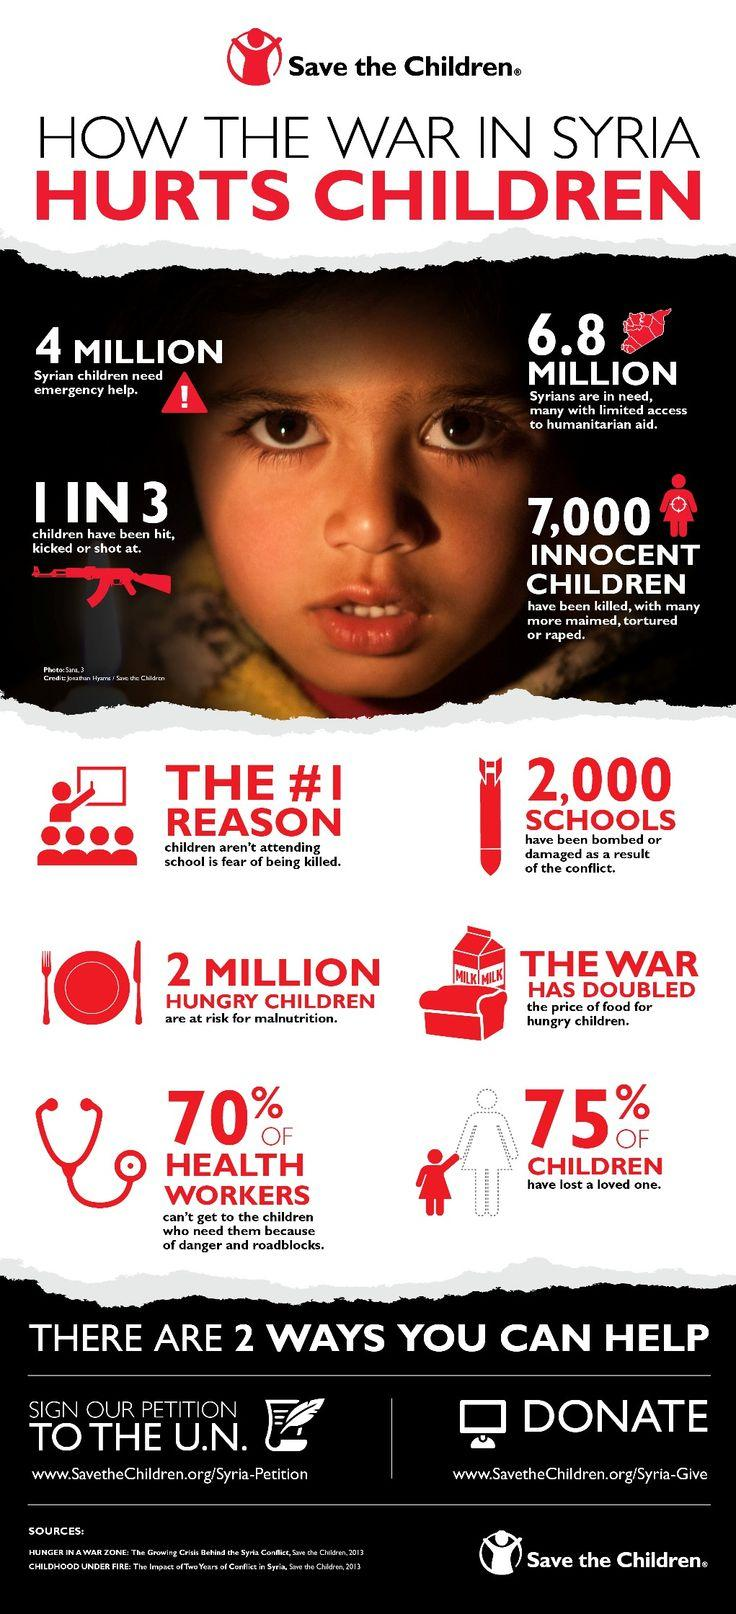Indicate a few pertinent items in this graphic. The color in which the words "HURTS CHILDREN" is written at the top is red. The color in which the words "HOW THE WAR IN SYRIA" is written at the top is black. In Syria, approximately 2 million children are at risk of being undernourished. In this image, the word "million" is written three times. 